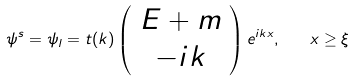<formula> <loc_0><loc_0><loc_500><loc_500>\psi ^ { s } = \psi _ { l } = t ( k ) \left ( \begin{array} { c } E + m \\ - i k \end{array} \right ) e ^ { i k x } , \quad x \geq \xi</formula> 